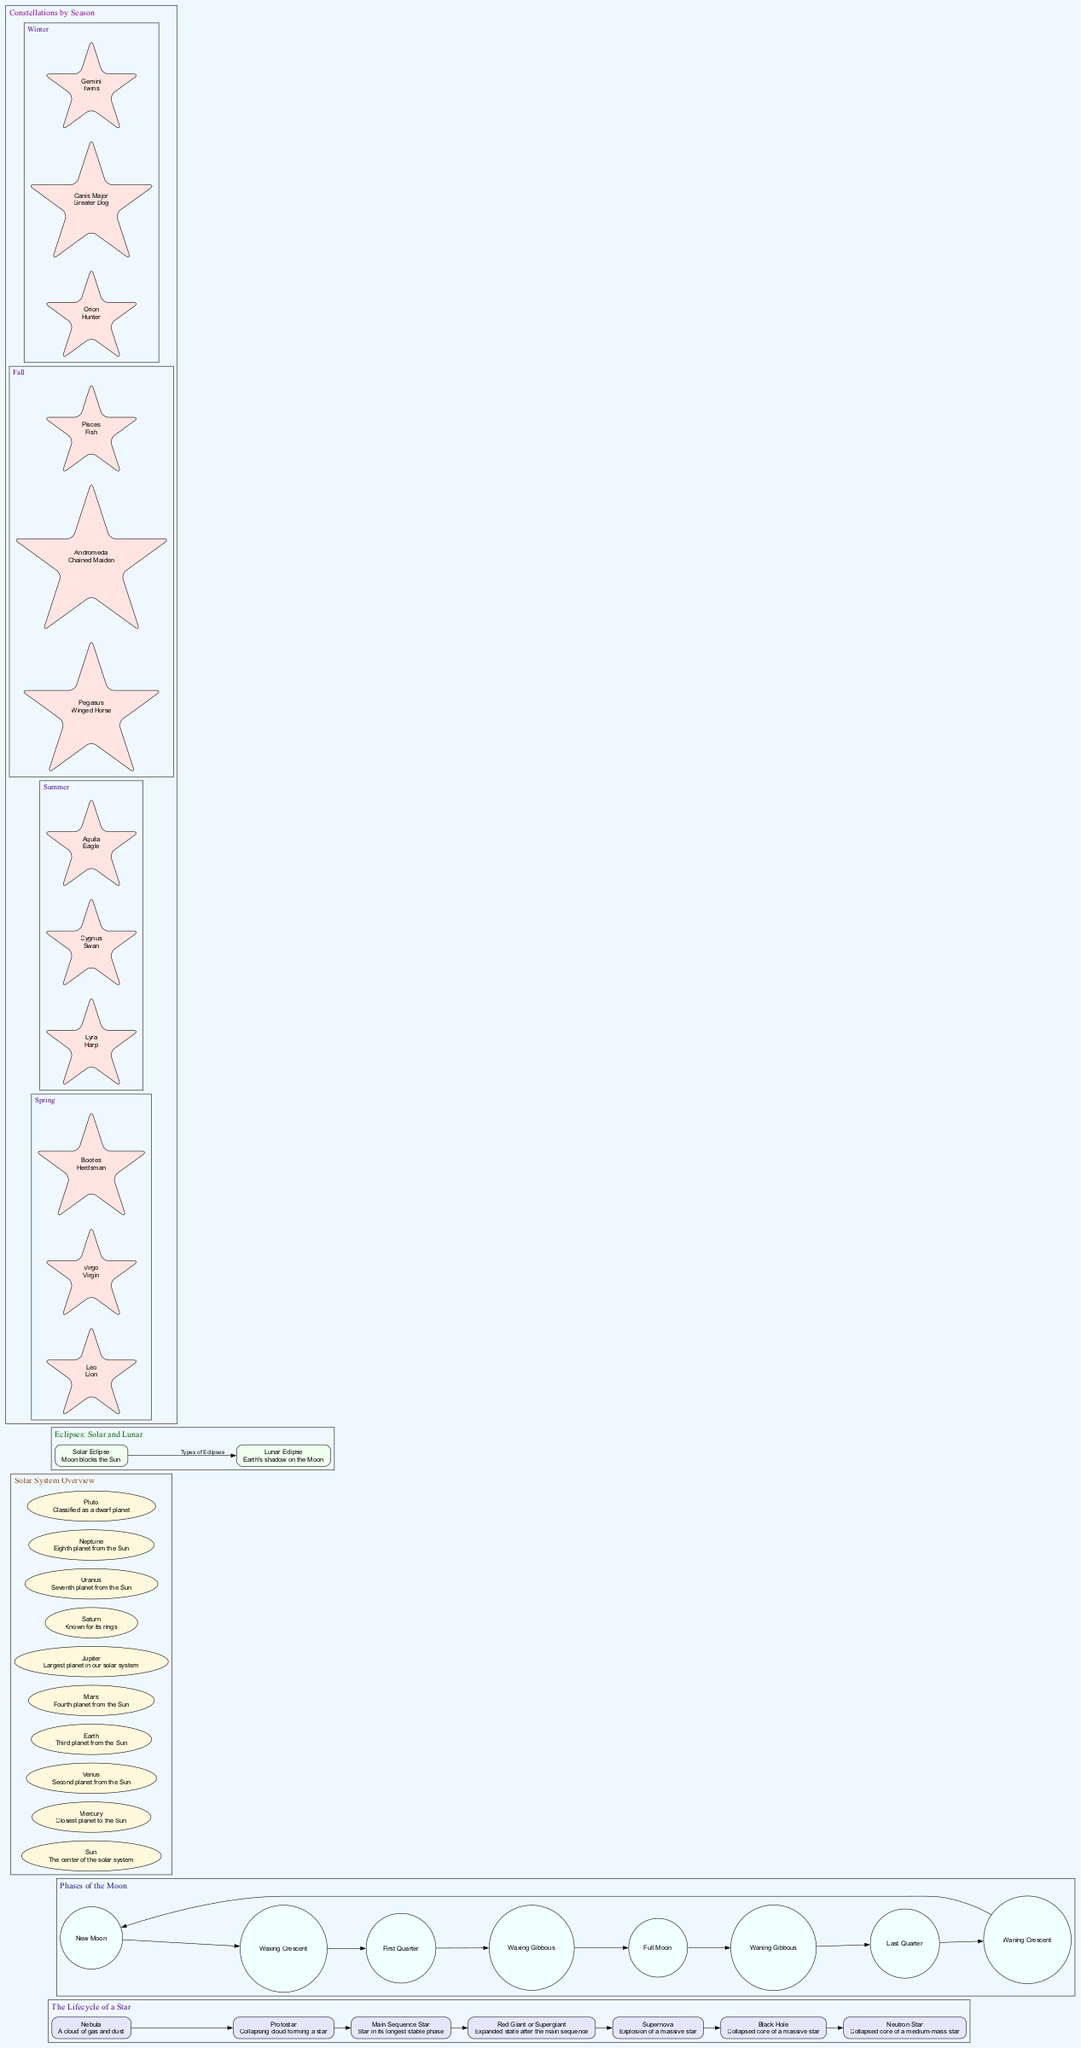What is the first stage in the Lifecycle of a Star? The diagram lists the stages in the Lifecycle of a Star with “Nebula” as the first stage.
Answer: Nebula How many phases are shown in the Phases of the Moon? The diagram includes a list of phases for the Moon, which shows a total of 8 distinct phases.
Answer: 8 What are the two final outcomes of a star's lifecycle? In the Lifecycle of a Star, the two final stages listed are "Black Hole" and "Neutron Star."
Answer: Black Hole or Neutron Star What alignment is necessary for a Solar Eclipse? The diagram indicates that for a Solar Eclipse, the alignment required is "Sun-Moon-Earth."
Answer: Sun-Moon-Earth Name one constellation visible in Winter. The Winter section of the Constellations by Season mentions "Orion" as one visible constellation.
Answer: Orion How many objects are included in the Solar System Overview? The diagram lists ten celestial objects, including the Sun and planets, confirming that there are a total of 10 objects shown.
Answer: 10 What type of star is the largest at the end of its lifecycle? The Lifecycle of a Star identifies "Supernova" as the explosive stage of a massive star, indicating it was once the largest before any collapse occurs.
Answer: Supernova Which phase follows the Waxing Gibbous? From the circular flow indicated in the Phases of the Moon, "Full Moon" is described as the phase that follows "Waxing Gibbous."
Answer: Full Moon What color represents the Sun in the Solar System Overview? The description in the diagram notes that the Sun is at the center, and the text associated with it usually represents "the center of the solar system." The color representation is not given in the text but typically, the Sun is depicted prominently, often in a bright yellow or orange.
Answer: Center of the Solar System 